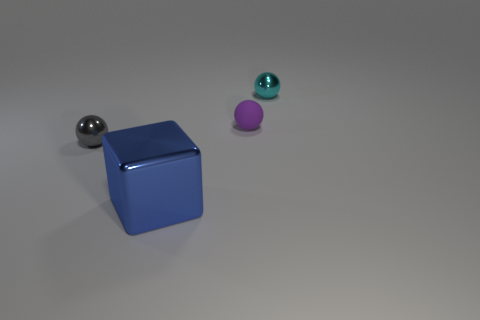What material is the purple sphere?
Your answer should be very brief. Rubber. How many small objects are either yellow things or shiny cubes?
Ensure brevity in your answer.  0. What number of blue blocks are in front of the tiny cyan metal object?
Provide a succinct answer. 1. Are there any spheres that have the same color as the big shiny thing?
Give a very brief answer. No. What shape is the cyan shiny thing that is the same size as the purple rubber sphere?
Ensure brevity in your answer.  Sphere. How many purple objects are either large blocks or tiny matte spheres?
Make the answer very short. 1. How many cyan metal spheres have the same size as the purple ball?
Provide a succinct answer. 1. How many objects are tiny purple matte balls or metal balls on the right side of the tiny matte thing?
Your answer should be compact. 2. There is a metal sphere that is in front of the cyan metal thing; is it the same size as the metal thing that is to the right of the big blue thing?
Provide a succinct answer. Yes. How many small rubber things are the same shape as the small gray metallic thing?
Make the answer very short. 1. 